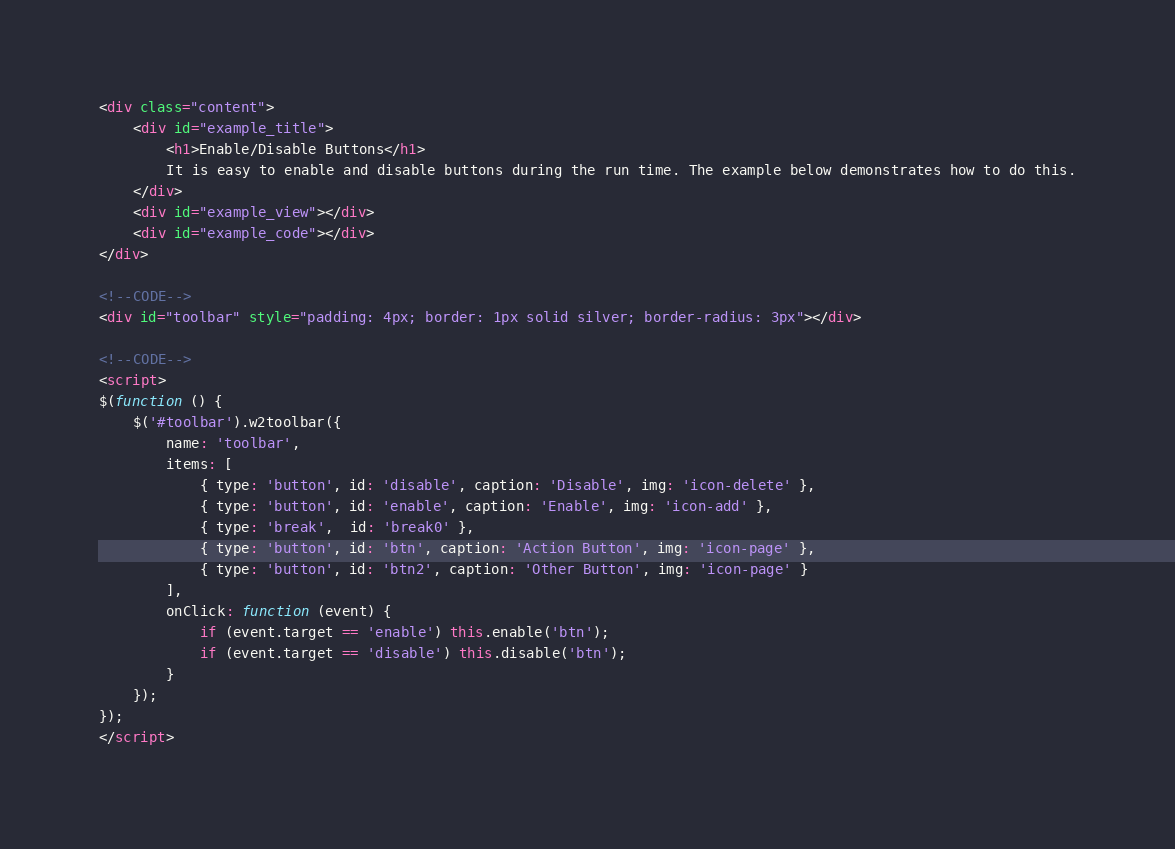Convert code to text. <code><loc_0><loc_0><loc_500><loc_500><_HTML_><div class="content">
	<div id="example_title">
		<h1>Enable/Disable Buttons</h1>
		It is easy to enable and disable buttons during the run time. The example below demonstrates how to do this.
	</div>
	<div id="example_view"></div>
	<div id="example_code"></div>
</div>

<!--CODE-->
<div id="toolbar" style="padding: 4px; border: 1px solid silver; border-radius: 3px"></div>

<!--CODE-->
<script>
$(function () {
	$('#toolbar').w2toolbar({
		name: 'toolbar',
		items: [
			{ type: 'button', id: 'disable', caption: 'Disable', img: 'icon-delete' },
			{ type: 'button', id: 'enable', caption: 'Enable', img: 'icon-add' },
			{ type: 'break',  id: 'break0' },
			{ type: 'button', id: 'btn', caption: 'Action Button', img: 'icon-page' },
			{ type: 'button', id: 'btn2', caption: 'Other Button', img: 'icon-page' }
		],
		onClick: function (event) {
			if (event.target == 'enable') this.enable('btn');
			if (event.target == 'disable') this.disable('btn');
		}
	});
});
</script>
</code> 